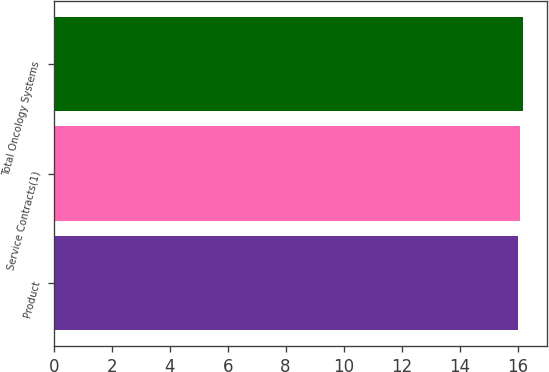<chart> <loc_0><loc_0><loc_500><loc_500><bar_chart><fcel>Product<fcel>Service Contracts(1)<fcel>Total Oncology Systems<nl><fcel>16<fcel>16.1<fcel>16.2<nl></chart> 